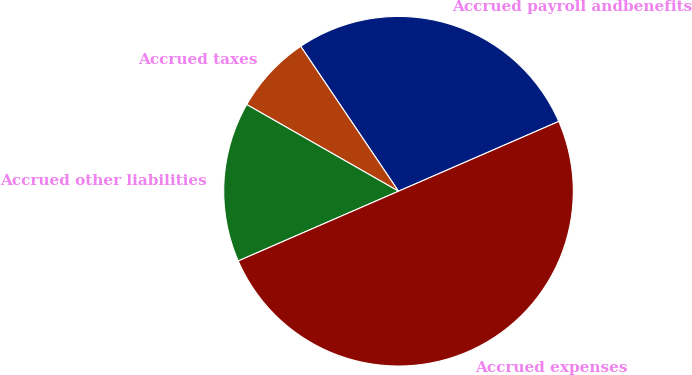Convert chart to OTSL. <chart><loc_0><loc_0><loc_500><loc_500><pie_chart><fcel>Accrued payroll andbenefits<fcel>Accrued taxes<fcel>Accrued other liabilities<fcel>Accrued expenses<nl><fcel>27.91%<fcel>7.29%<fcel>14.79%<fcel>50.0%<nl></chart> 